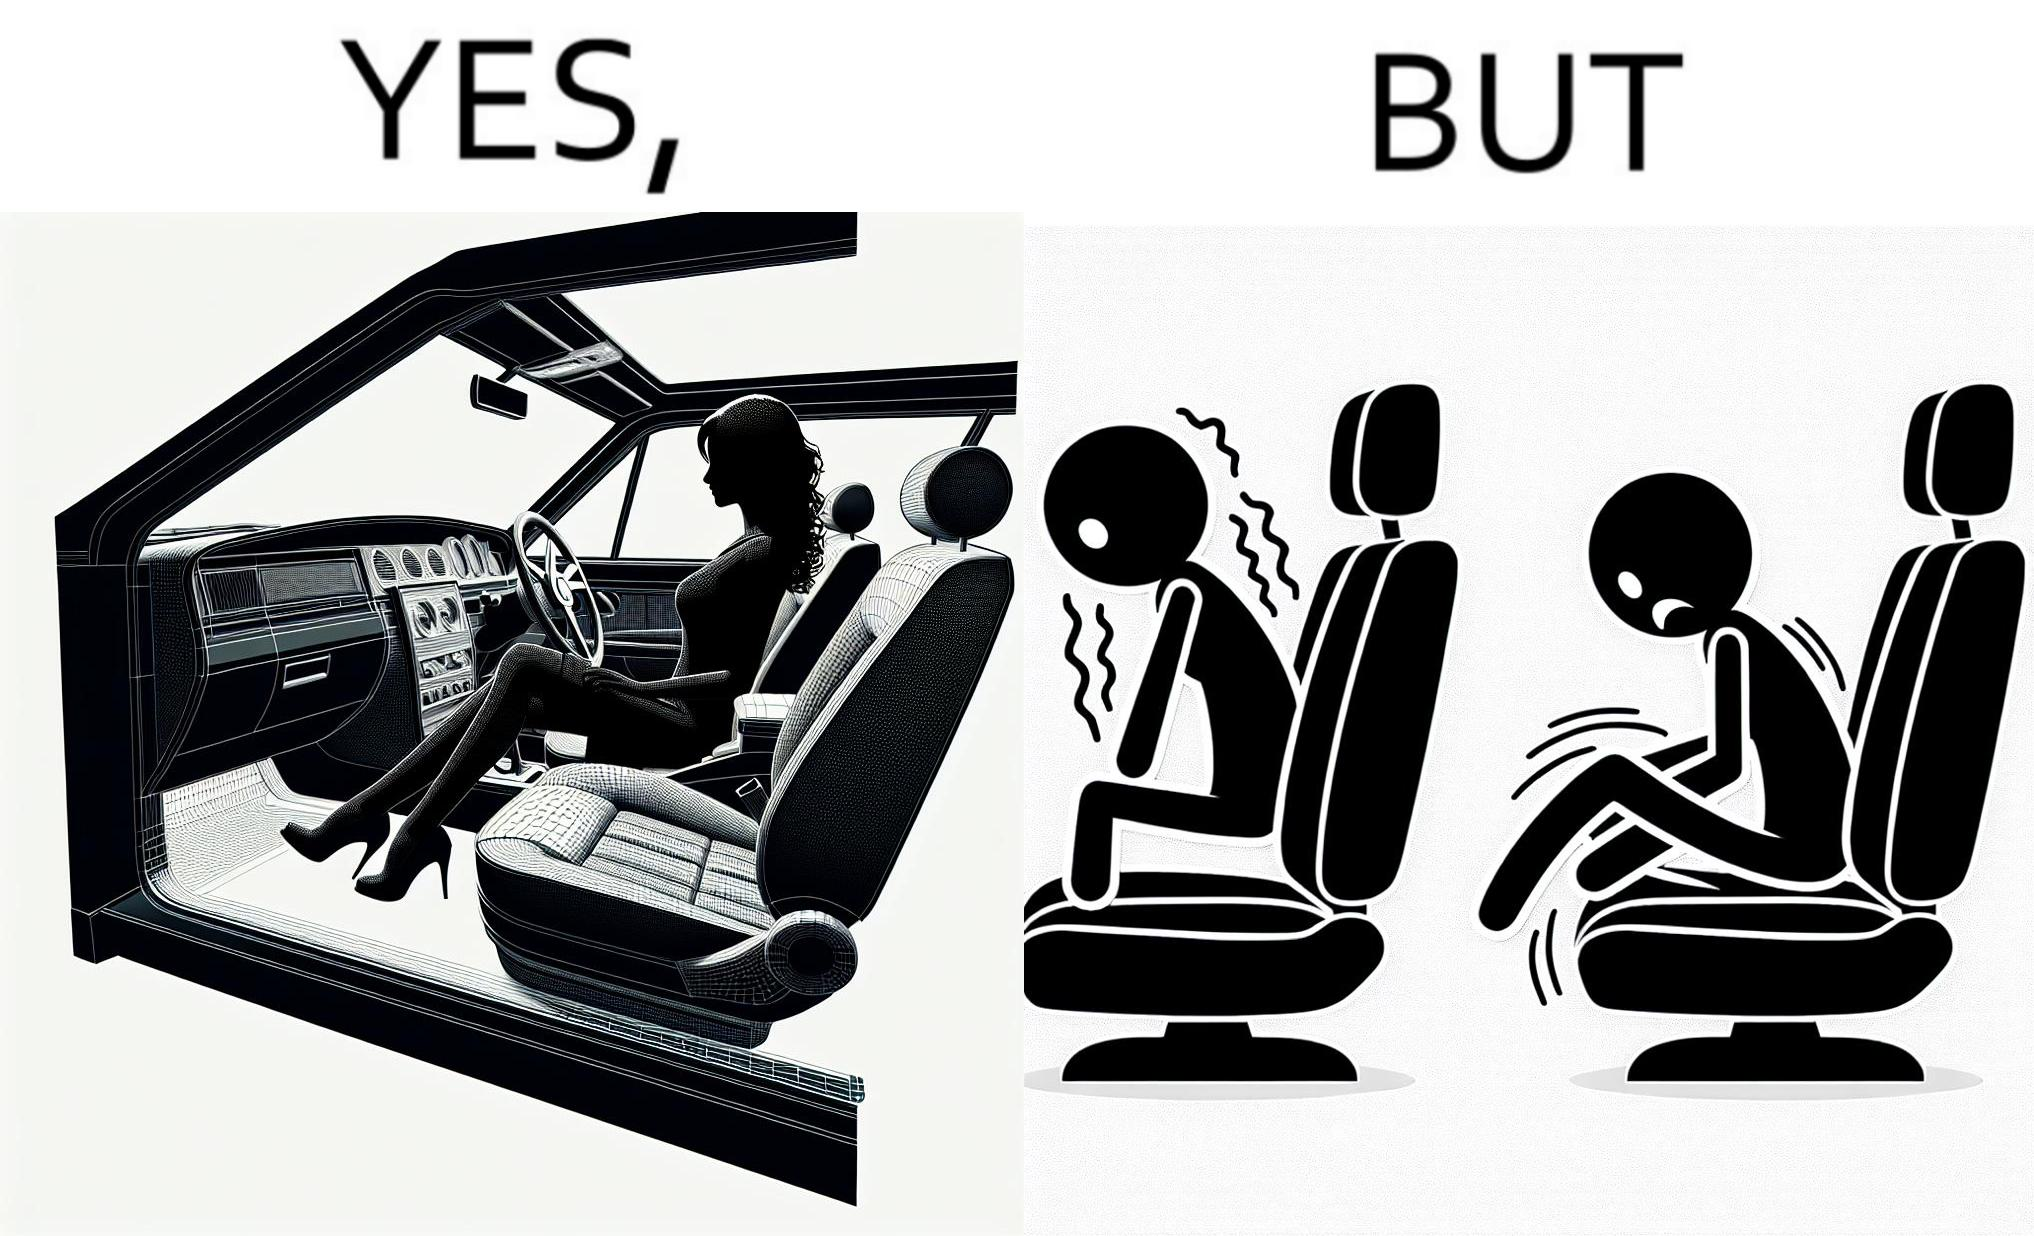Describe what you see in this image. The image is ironic, because the woman is wearing a short dress to look stylish but she had to face inconvenience while travelling in car due to her short dress only. 